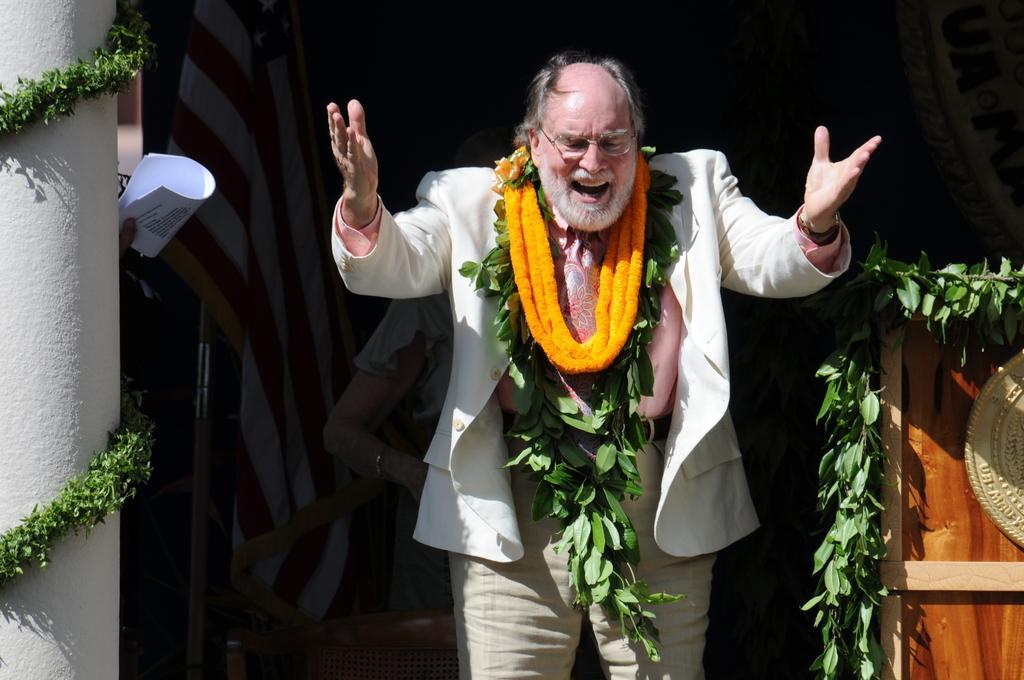How would you summarize this image in a sentence or two? Here we can see a man standing and there are garlands on his neck. In the background we can see a pillar,leaves,podium,chair and a woman and papers in a person hand. 